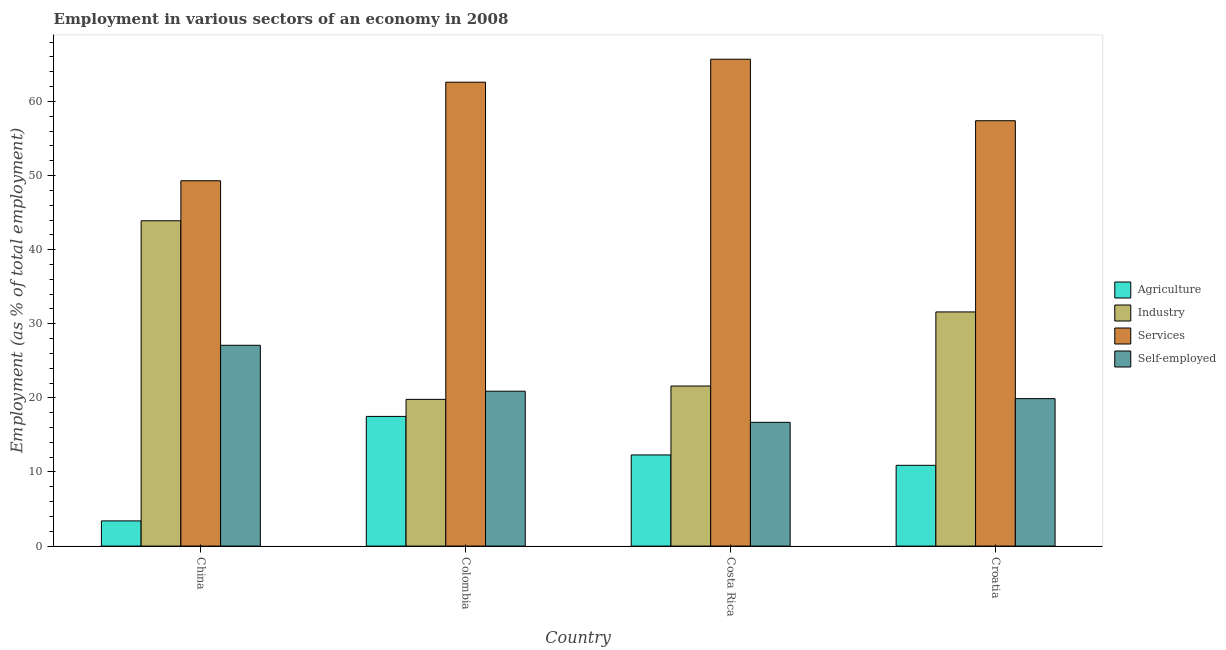How many different coloured bars are there?
Your response must be concise. 4. Are the number of bars per tick equal to the number of legend labels?
Your response must be concise. Yes. Are the number of bars on each tick of the X-axis equal?
Ensure brevity in your answer.  Yes. How many bars are there on the 1st tick from the left?
Keep it short and to the point. 4. What is the percentage of workers in services in Colombia?
Give a very brief answer. 62.6. Across all countries, what is the maximum percentage of workers in services?
Offer a very short reply. 65.7. Across all countries, what is the minimum percentage of workers in services?
Give a very brief answer. 49.3. In which country was the percentage of workers in services maximum?
Make the answer very short. Costa Rica. In which country was the percentage of workers in industry minimum?
Your response must be concise. Colombia. What is the total percentage of workers in agriculture in the graph?
Your answer should be compact. 44.1. What is the difference between the percentage of workers in industry in China and that in Costa Rica?
Make the answer very short. 22.3. What is the difference between the percentage of workers in services in Costa Rica and the percentage of workers in agriculture in Colombia?
Your answer should be very brief. 48.2. What is the average percentage of workers in agriculture per country?
Provide a succinct answer. 11.02. What is the difference between the percentage of workers in services and percentage of workers in industry in China?
Your response must be concise. 5.4. In how many countries, is the percentage of workers in services greater than 44 %?
Make the answer very short. 4. What is the ratio of the percentage of workers in services in Colombia to that in Costa Rica?
Give a very brief answer. 0.95. Is the percentage of workers in industry in Costa Rica less than that in Croatia?
Make the answer very short. Yes. What is the difference between the highest and the second highest percentage of workers in agriculture?
Your answer should be very brief. 5.2. What is the difference between the highest and the lowest percentage of workers in agriculture?
Your answer should be very brief. 14.1. What does the 4th bar from the left in Costa Rica represents?
Keep it short and to the point. Self-employed. What does the 3rd bar from the right in Costa Rica represents?
Make the answer very short. Industry. Is it the case that in every country, the sum of the percentage of workers in agriculture and percentage of workers in industry is greater than the percentage of workers in services?
Make the answer very short. No. Are all the bars in the graph horizontal?
Make the answer very short. No. Are the values on the major ticks of Y-axis written in scientific E-notation?
Provide a short and direct response. No. Does the graph contain grids?
Keep it short and to the point. No. How many legend labels are there?
Provide a succinct answer. 4. What is the title of the graph?
Make the answer very short. Employment in various sectors of an economy in 2008. Does "UNRWA" appear as one of the legend labels in the graph?
Your answer should be compact. No. What is the label or title of the Y-axis?
Give a very brief answer. Employment (as % of total employment). What is the Employment (as % of total employment) in Agriculture in China?
Give a very brief answer. 3.4. What is the Employment (as % of total employment) of Industry in China?
Provide a short and direct response. 43.9. What is the Employment (as % of total employment) of Services in China?
Ensure brevity in your answer.  49.3. What is the Employment (as % of total employment) of Self-employed in China?
Make the answer very short. 27.1. What is the Employment (as % of total employment) of Agriculture in Colombia?
Provide a short and direct response. 17.5. What is the Employment (as % of total employment) in Industry in Colombia?
Give a very brief answer. 19.8. What is the Employment (as % of total employment) in Services in Colombia?
Keep it short and to the point. 62.6. What is the Employment (as % of total employment) in Self-employed in Colombia?
Offer a terse response. 20.9. What is the Employment (as % of total employment) of Agriculture in Costa Rica?
Provide a succinct answer. 12.3. What is the Employment (as % of total employment) in Industry in Costa Rica?
Provide a succinct answer. 21.6. What is the Employment (as % of total employment) in Services in Costa Rica?
Provide a short and direct response. 65.7. What is the Employment (as % of total employment) in Self-employed in Costa Rica?
Provide a short and direct response. 16.7. What is the Employment (as % of total employment) in Agriculture in Croatia?
Make the answer very short. 10.9. What is the Employment (as % of total employment) of Industry in Croatia?
Your answer should be very brief. 31.6. What is the Employment (as % of total employment) in Services in Croatia?
Make the answer very short. 57.4. What is the Employment (as % of total employment) in Self-employed in Croatia?
Your response must be concise. 19.9. Across all countries, what is the maximum Employment (as % of total employment) of Industry?
Make the answer very short. 43.9. Across all countries, what is the maximum Employment (as % of total employment) of Services?
Provide a short and direct response. 65.7. Across all countries, what is the maximum Employment (as % of total employment) of Self-employed?
Offer a terse response. 27.1. Across all countries, what is the minimum Employment (as % of total employment) in Agriculture?
Your response must be concise. 3.4. Across all countries, what is the minimum Employment (as % of total employment) of Industry?
Offer a terse response. 19.8. Across all countries, what is the minimum Employment (as % of total employment) of Services?
Your response must be concise. 49.3. Across all countries, what is the minimum Employment (as % of total employment) in Self-employed?
Your answer should be compact. 16.7. What is the total Employment (as % of total employment) in Agriculture in the graph?
Make the answer very short. 44.1. What is the total Employment (as % of total employment) of Industry in the graph?
Your response must be concise. 116.9. What is the total Employment (as % of total employment) of Services in the graph?
Provide a short and direct response. 235. What is the total Employment (as % of total employment) in Self-employed in the graph?
Your answer should be very brief. 84.6. What is the difference between the Employment (as % of total employment) of Agriculture in China and that in Colombia?
Keep it short and to the point. -14.1. What is the difference between the Employment (as % of total employment) in Industry in China and that in Colombia?
Provide a succinct answer. 24.1. What is the difference between the Employment (as % of total employment) of Services in China and that in Colombia?
Offer a terse response. -13.3. What is the difference between the Employment (as % of total employment) of Self-employed in China and that in Colombia?
Your answer should be very brief. 6.2. What is the difference between the Employment (as % of total employment) of Industry in China and that in Costa Rica?
Your response must be concise. 22.3. What is the difference between the Employment (as % of total employment) of Services in China and that in Costa Rica?
Ensure brevity in your answer.  -16.4. What is the difference between the Employment (as % of total employment) of Self-employed in China and that in Costa Rica?
Offer a very short reply. 10.4. What is the difference between the Employment (as % of total employment) in Agriculture in China and that in Croatia?
Your answer should be very brief. -7.5. What is the difference between the Employment (as % of total employment) in Industry in China and that in Croatia?
Offer a terse response. 12.3. What is the difference between the Employment (as % of total employment) in Services in China and that in Croatia?
Make the answer very short. -8.1. What is the difference between the Employment (as % of total employment) of Agriculture in Colombia and that in Costa Rica?
Offer a very short reply. 5.2. What is the difference between the Employment (as % of total employment) in Self-employed in Colombia and that in Costa Rica?
Your response must be concise. 4.2. What is the difference between the Employment (as % of total employment) of Industry in Colombia and that in Croatia?
Your answer should be compact. -11.8. What is the difference between the Employment (as % of total employment) in Industry in Costa Rica and that in Croatia?
Give a very brief answer. -10. What is the difference between the Employment (as % of total employment) of Services in Costa Rica and that in Croatia?
Provide a succinct answer. 8.3. What is the difference between the Employment (as % of total employment) of Self-employed in Costa Rica and that in Croatia?
Provide a succinct answer. -3.2. What is the difference between the Employment (as % of total employment) of Agriculture in China and the Employment (as % of total employment) of Industry in Colombia?
Ensure brevity in your answer.  -16.4. What is the difference between the Employment (as % of total employment) of Agriculture in China and the Employment (as % of total employment) of Services in Colombia?
Your answer should be very brief. -59.2. What is the difference between the Employment (as % of total employment) of Agriculture in China and the Employment (as % of total employment) of Self-employed in Colombia?
Your answer should be compact. -17.5. What is the difference between the Employment (as % of total employment) of Industry in China and the Employment (as % of total employment) of Services in Colombia?
Give a very brief answer. -18.7. What is the difference between the Employment (as % of total employment) of Services in China and the Employment (as % of total employment) of Self-employed in Colombia?
Offer a terse response. 28.4. What is the difference between the Employment (as % of total employment) of Agriculture in China and the Employment (as % of total employment) of Industry in Costa Rica?
Provide a short and direct response. -18.2. What is the difference between the Employment (as % of total employment) of Agriculture in China and the Employment (as % of total employment) of Services in Costa Rica?
Your response must be concise. -62.3. What is the difference between the Employment (as % of total employment) of Industry in China and the Employment (as % of total employment) of Services in Costa Rica?
Your answer should be very brief. -21.8. What is the difference between the Employment (as % of total employment) of Industry in China and the Employment (as % of total employment) of Self-employed in Costa Rica?
Your answer should be compact. 27.2. What is the difference between the Employment (as % of total employment) in Services in China and the Employment (as % of total employment) in Self-employed in Costa Rica?
Give a very brief answer. 32.6. What is the difference between the Employment (as % of total employment) of Agriculture in China and the Employment (as % of total employment) of Industry in Croatia?
Your answer should be compact. -28.2. What is the difference between the Employment (as % of total employment) of Agriculture in China and the Employment (as % of total employment) of Services in Croatia?
Provide a succinct answer. -54. What is the difference between the Employment (as % of total employment) of Agriculture in China and the Employment (as % of total employment) of Self-employed in Croatia?
Your response must be concise. -16.5. What is the difference between the Employment (as % of total employment) in Industry in China and the Employment (as % of total employment) in Self-employed in Croatia?
Offer a very short reply. 24. What is the difference between the Employment (as % of total employment) of Services in China and the Employment (as % of total employment) of Self-employed in Croatia?
Provide a short and direct response. 29.4. What is the difference between the Employment (as % of total employment) in Agriculture in Colombia and the Employment (as % of total employment) in Industry in Costa Rica?
Provide a succinct answer. -4.1. What is the difference between the Employment (as % of total employment) in Agriculture in Colombia and the Employment (as % of total employment) in Services in Costa Rica?
Keep it short and to the point. -48.2. What is the difference between the Employment (as % of total employment) of Agriculture in Colombia and the Employment (as % of total employment) of Self-employed in Costa Rica?
Your answer should be very brief. 0.8. What is the difference between the Employment (as % of total employment) in Industry in Colombia and the Employment (as % of total employment) in Services in Costa Rica?
Give a very brief answer. -45.9. What is the difference between the Employment (as % of total employment) of Services in Colombia and the Employment (as % of total employment) of Self-employed in Costa Rica?
Ensure brevity in your answer.  45.9. What is the difference between the Employment (as % of total employment) in Agriculture in Colombia and the Employment (as % of total employment) in Industry in Croatia?
Make the answer very short. -14.1. What is the difference between the Employment (as % of total employment) of Agriculture in Colombia and the Employment (as % of total employment) of Services in Croatia?
Your answer should be very brief. -39.9. What is the difference between the Employment (as % of total employment) of Agriculture in Colombia and the Employment (as % of total employment) of Self-employed in Croatia?
Ensure brevity in your answer.  -2.4. What is the difference between the Employment (as % of total employment) in Industry in Colombia and the Employment (as % of total employment) in Services in Croatia?
Your answer should be compact. -37.6. What is the difference between the Employment (as % of total employment) in Industry in Colombia and the Employment (as % of total employment) in Self-employed in Croatia?
Provide a succinct answer. -0.1. What is the difference between the Employment (as % of total employment) in Services in Colombia and the Employment (as % of total employment) in Self-employed in Croatia?
Offer a terse response. 42.7. What is the difference between the Employment (as % of total employment) of Agriculture in Costa Rica and the Employment (as % of total employment) of Industry in Croatia?
Your answer should be compact. -19.3. What is the difference between the Employment (as % of total employment) in Agriculture in Costa Rica and the Employment (as % of total employment) in Services in Croatia?
Provide a succinct answer. -45.1. What is the difference between the Employment (as % of total employment) in Agriculture in Costa Rica and the Employment (as % of total employment) in Self-employed in Croatia?
Provide a short and direct response. -7.6. What is the difference between the Employment (as % of total employment) of Industry in Costa Rica and the Employment (as % of total employment) of Services in Croatia?
Offer a terse response. -35.8. What is the difference between the Employment (as % of total employment) of Industry in Costa Rica and the Employment (as % of total employment) of Self-employed in Croatia?
Ensure brevity in your answer.  1.7. What is the difference between the Employment (as % of total employment) in Services in Costa Rica and the Employment (as % of total employment) in Self-employed in Croatia?
Give a very brief answer. 45.8. What is the average Employment (as % of total employment) in Agriculture per country?
Keep it short and to the point. 11.03. What is the average Employment (as % of total employment) in Industry per country?
Your answer should be compact. 29.23. What is the average Employment (as % of total employment) of Services per country?
Give a very brief answer. 58.75. What is the average Employment (as % of total employment) of Self-employed per country?
Provide a succinct answer. 21.15. What is the difference between the Employment (as % of total employment) in Agriculture and Employment (as % of total employment) in Industry in China?
Your response must be concise. -40.5. What is the difference between the Employment (as % of total employment) of Agriculture and Employment (as % of total employment) of Services in China?
Provide a succinct answer. -45.9. What is the difference between the Employment (as % of total employment) of Agriculture and Employment (as % of total employment) of Self-employed in China?
Offer a very short reply. -23.7. What is the difference between the Employment (as % of total employment) in Industry and Employment (as % of total employment) in Services in China?
Your response must be concise. -5.4. What is the difference between the Employment (as % of total employment) in Industry and Employment (as % of total employment) in Self-employed in China?
Offer a very short reply. 16.8. What is the difference between the Employment (as % of total employment) of Agriculture and Employment (as % of total employment) of Industry in Colombia?
Ensure brevity in your answer.  -2.3. What is the difference between the Employment (as % of total employment) of Agriculture and Employment (as % of total employment) of Services in Colombia?
Your response must be concise. -45.1. What is the difference between the Employment (as % of total employment) in Industry and Employment (as % of total employment) in Services in Colombia?
Give a very brief answer. -42.8. What is the difference between the Employment (as % of total employment) of Industry and Employment (as % of total employment) of Self-employed in Colombia?
Your answer should be very brief. -1.1. What is the difference between the Employment (as % of total employment) in Services and Employment (as % of total employment) in Self-employed in Colombia?
Your answer should be very brief. 41.7. What is the difference between the Employment (as % of total employment) of Agriculture and Employment (as % of total employment) of Industry in Costa Rica?
Provide a succinct answer. -9.3. What is the difference between the Employment (as % of total employment) in Agriculture and Employment (as % of total employment) in Services in Costa Rica?
Make the answer very short. -53.4. What is the difference between the Employment (as % of total employment) of Industry and Employment (as % of total employment) of Services in Costa Rica?
Offer a terse response. -44.1. What is the difference between the Employment (as % of total employment) of Agriculture and Employment (as % of total employment) of Industry in Croatia?
Offer a very short reply. -20.7. What is the difference between the Employment (as % of total employment) in Agriculture and Employment (as % of total employment) in Services in Croatia?
Give a very brief answer. -46.5. What is the difference between the Employment (as % of total employment) of Industry and Employment (as % of total employment) of Services in Croatia?
Keep it short and to the point. -25.8. What is the difference between the Employment (as % of total employment) of Industry and Employment (as % of total employment) of Self-employed in Croatia?
Your answer should be compact. 11.7. What is the difference between the Employment (as % of total employment) in Services and Employment (as % of total employment) in Self-employed in Croatia?
Give a very brief answer. 37.5. What is the ratio of the Employment (as % of total employment) in Agriculture in China to that in Colombia?
Provide a succinct answer. 0.19. What is the ratio of the Employment (as % of total employment) in Industry in China to that in Colombia?
Keep it short and to the point. 2.22. What is the ratio of the Employment (as % of total employment) in Services in China to that in Colombia?
Your answer should be very brief. 0.79. What is the ratio of the Employment (as % of total employment) in Self-employed in China to that in Colombia?
Keep it short and to the point. 1.3. What is the ratio of the Employment (as % of total employment) in Agriculture in China to that in Costa Rica?
Offer a very short reply. 0.28. What is the ratio of the Employment (as % of total employment) of Industry in China to that in Costa Rica?
Offer a very short reply. 2.03. What is the ratio of the Employment (as % of total employment) of Services in China to that in Costa Rica?
Your response must be concise. 0.75. What is the ratio of the Employment (as % of total employment) in Self-employed in China to that in Costa Rica?
Your answer should be very brief. 1.62. What is the ratio of the Employment (as % of total employment) in Agriculture in China to that in Croatia?
Your response must be concise. 0.31. What is the ratio of the Employment (as % of total employment) of Industry in China to that in Croatia?
Your answer should be compact. 1.39. What is the ratio of the Employment (as % of total employment) of Services in China to that in Croatia?
Offer a terse response. 0.86. What is the ratio of the Employment (as % of total employment) of Self-employed in China to that in Croatia?
Offer a very short reply. 1.36. What is the ratio of the Employment (as % of total employment) of Agriculture in Colombia to that in Costa Rica?
Offer a very short reply. 1.42. What is the ratio of the Employment (as % of total employment) of Industry in Colombia to that in Costa Rica?
Keep it short and to the point. 0.92. What is the ratio of the Employment (as % of total employment) in Services in Colombia to that in Costa Rica?
Offer a very short reply. 0.95. What is the ratio of the Employment (as % of total employment) in Self-employed in Colombia to that in Costa Rica?
Keep it short and to the point. 1.25. What is the ratio of the Employment (as % of total employment) of Agriculture in Colombia to that in Croatia?
Offer a very short reply. 1.61. What is the ratio of the Employment (as % of total employment) in Industry in Colombia to that in Croatia?
Your answer should be very brief. 0.63. What is the ratio of the Employment (as % of total employment) of Services in Colombia to that in Croatia?
Provide a short and direct response. 1.09. What is the ratio of the Employment (as % of total employment) in Self-employed in Colombia to that in Croatia?
Offer a very short reply. 1.05. What is the ratio of the Employment (as % of total employment) of Agriculture in Costa Rica to that in Croatia?
Offer a very short reply. 1.13. What is the ratio of the Employment (as % of total employment) in Industry in Costa Rica to that in Croatia?
Offer a very short reply. 0.68. What is the ratio of the Employment (as % of total employment) in Services in Costa Rica to that in Croatia?
Keep it short and to the point. 1.14. What is the ratio of the Employment (as % of total employment) in Self-employed in Costa Rica to that in Croatia?
Your response must be concise. 0.84. What is the difference between the highest and the second highest Employment (as % of total employment) of Services?
Offer a terse response. 3.1. What is the difference between the highest and the second highest Employment (as % of total employment) in Self-employed?
Your answer should be compact. 6.2. What is the difference between the highest and the lowest Employment (as % of total employment) of Industry?
Give a very brief answer. 24.1. What is the difference between the highest and the lowest Employment (as % of total employment) in Services?
Provide a short and direct response. 16.4. 